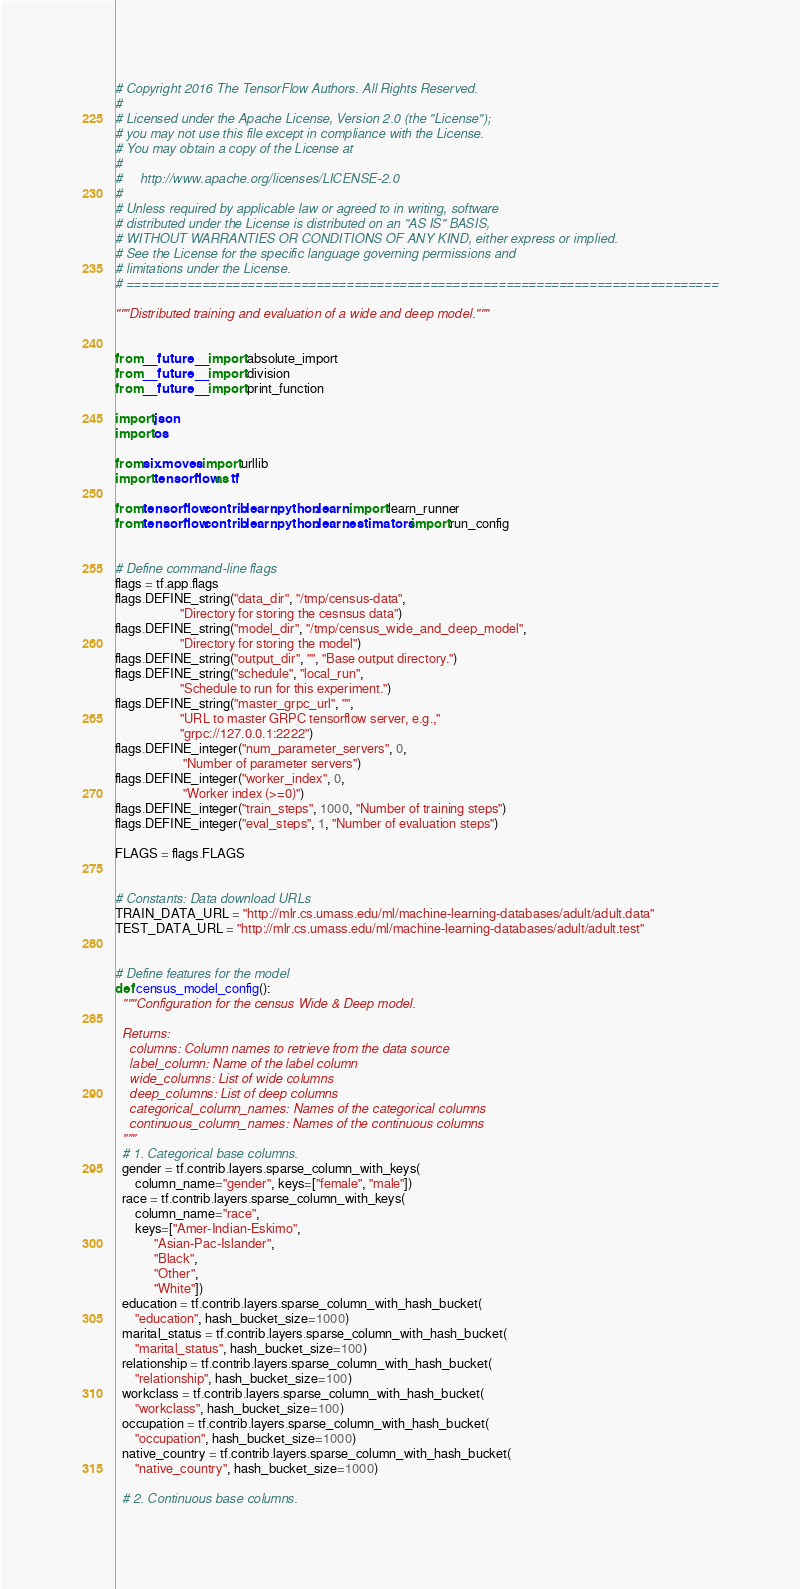Convert code to text. <code><loc_0><loc_0><loc_500><loc_500><_Python_># Copyright 2016 The TensorFlow Authors. All Rights Reserved.
#
# Licensed under the Apache License, Version 2.0 (the "License");
# you may not use this file except in compliance with the License.
# You may obtain a copy of the License at
#
#     http://www.apache.org/licenses/LICENSE-2.0
#
# Unless required by applicable law or agreed to in writing, software
# distributed under the License is distributed on an "AS IS" BASIS,
# WITHOUT WARRANTIES OR CONDITIONS OF ANY KIND, either express or implied.
# See the License for the specific language governing permissions and
# limitations under the License.
# ==============================================================================

"""Distributed training and evaluation of a wide and deep model."""


from __future__ import absolute_import
from __future__ import division
from __future__ import print_function

import json
import os

from six.moves import urllib
import tensorflow as tf

from tensorflow.contrib.learn.python.learn import learn_runner
from tensorflow.contrib.learn.python.learn.estimators import run_config


# Define command-line flags
flags = tf.app.flags
flags.DEFINE_string("data_dir", "/tmp/census-data",
                    "Directory for storing the cesnsus data")
flags.DEFINE_string("model_dir", "/tmp/census_wide_and_deep_model",
                    "Directory for storing the model")
flags.DEFINE_string("output_dir", "", "Base output directory.")
flags.DEFINE_string("schedule", "local_run",
                    "Schedule to run for this experiment.")
flags.DEFINE_string("master_grpc_url", "",
                    "URL to master GRPC tensorflow server, e.g.,"
                    "grpc://127.0.0.1:2222")
flags.DEFINE_integer("num_parameter_servers", 0,
                     "Number of parameter servers")
flags.DEFINE_integer("worker_index", 0,
                     "Worker index (>=0)")
flags.DEFINE_integer("train_steps", 1000, "Number of training steps")
flags.DEFINE_integer("eval_steps", 1, "Number of evaluation steps")

FLAGS = flags.FLAGS


# Constants: Data download URLs
TRAIN_DATA_URL = "http://mlr.cs.umass.edu/ml/machine-learning-databases/adult/adult.data"
TEST_DATA_URL = "http://mlr.cs.umass.edu/ml/machine-learning-databases/adult/adult.test"


# Define features for the model
def census_model_config():
  """Configuration for the census Wide & Deep model.

  Returns:
    columns: Column names to retrieve from the data source
    label_column: Name of the label column
    wide_columns: List of wide columns
    deep_columns: List of deep columns
    categorical_column_names: Names of the categorical columns
    continuous_column_names: Names of the continuous columns
  """
  # 1. Categorical base columns.
  gender = tf.contrib.layers.sparse_column_with_keys(
      column_name="gender", keys=["female", "male"])
  race = tf.contrib.layers.sparse_column_with_keys(
      column_name="race",
      keys=["Amer-Indian-Eskimo",
            "Asian-Pac-Islander",
            "Black",
            "Other",
            "White"])
  education = tf.contrib.layers.sparse_column_with_hash_bucket(
      "education", hash_bucket_size=1000)
  marital_status = tf.contrib.layers.sparse_column_with_hash_bucket(
      "marital_status", hash_bucket_size=100)
  relationship = tf.contrib.layers.sparse_column_with_hash_bucket(
      "relationship", hash_bucket_size=100)
  workclass = tf.contrib.layers.sparse_column_with_hash_bucket(
      "workclass", hash_bucket_size=100)
  occupation = tf.contrib.layers.sparse_column_with_hash_bucket(
      "occupation", hash_bucket_size=1000)
  native_country = tf.contrib.layers.sparse_column_with_hash_bucket(
      "native_country", hash_bucket_size=1000)

  # 2. Continuous base columns.</code> 